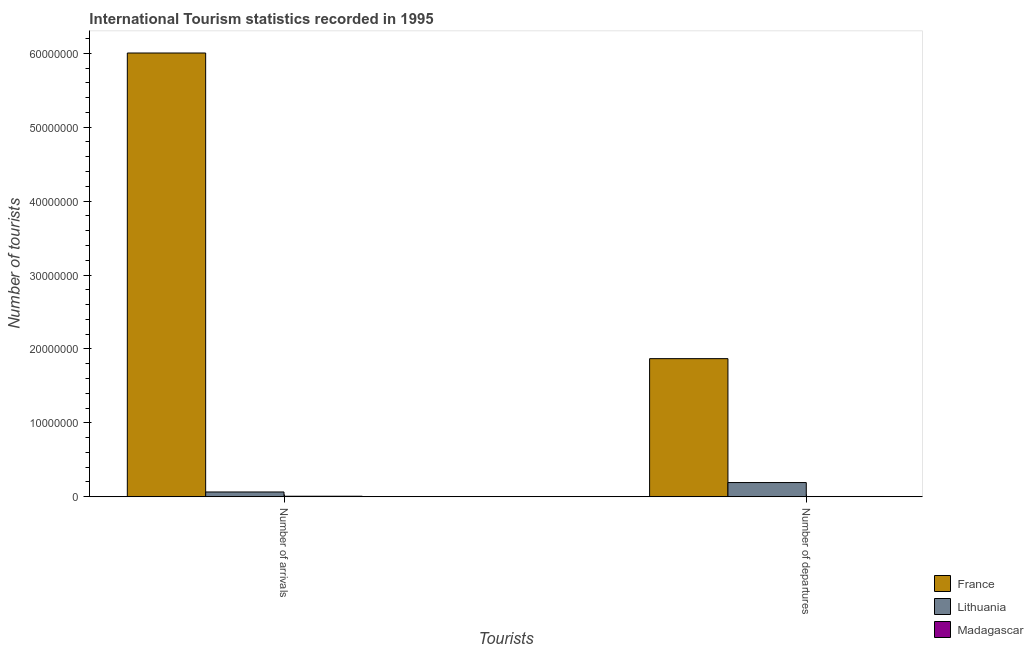Are the number of bars per tick equal to the number of legend labels?
Your answer should be very brief. Yes. What is the label of the 2nd group of bars from the left?
Provide a short and direct response. Number of departures. What is the number of tourist arrivals in France?
Offer a terse response. 6.00e+07. Across all countries, what is the maximum number of tourist departures?
Make the answer very short. 1.87e+07. Across all countries, what is the minimum number of tourist arrivals?
Your answer should be compact. 7.50e+04. In which country was the number of tourist arrivals minimum?
Make the answer very short. Madagascar. What is the total number of tourist arrivals in the graph?
Ensure brevity in your answer.  6.08e+07. What is the difference between the number of tourist arrivals in France and that in Madagascar?
Provide a short and direct response. 6.00e+07. What is the difference between the number of tourist arrivals in Madagascar and the number of tourist departures in France?
Your response must be concise. -1.86e+07. What is the average number of tourist departures per country?
Give a very brief answer. 6.88e+06. What is the difference between the number of tourist arrivals and number of tourist departures in Madagascar?
Give a very brief answer. 3.60e+04. In how many countries, is the number of tourist arrivals greater than 46000000 ?
Ensure brevity in your answer.  1. What is the ratio of the number of tourist arrivals in France to that in Lithuania?
Keep it short and to the point. 92.36. Is the number of tourist departures in Lithuania less than that in France?
Provide a succinct answer. Yes. In how many countries, is the number of tourist arrivals greater than the average number of tourist arrivals taken over all countries?
Ensure brevity in your answer.  1. What does the 1st bar from the left in Number of departures represents?
Your answer should be compact. France. What does the 1st bar from the right in Number of arrivals represents?
Your answer should be very brief. Madagascar. How many bars are there?
Offer a very short reply. 6. Does the graph contain any zero values?
Give a very brief answer. No. How are the legend labels stacked?
Your answer should be very brief. Vertical. What is the title of the graph?
Your answer should be very brief. International Tourism statistics recorded in 1995. Does "Hungary" appear as one of the legend labels in the graph?
Make the answer very short. No. What is the label or title of the X-axis?
Your answer should be very brief. Tourists. What is the label or title of the Y-axis?
Provide a short and direct response. Number of tourists. What is the Number of tourists in France in Number of arrivals?
Ensure brevity in your answer.  6.00e+07. What is the Number of tourists of Lithuania in Number of arrivals?
Keep it short and to the point. 6.50e+05. What is the Number of tourists of Madagascar in Number of arrivals?
Offer a very short reply. 7.50e+04. What is the Number of tourists of France in Number of departures?
Your response must be concise. 1.87e+07. What is the Number of tourists in Lithuania in Number of departures?
Ensure brevity in your answer.  1.92e+06. What is the Number of tourists in Madagascar in Number of departures?
Offer a very short reply. 3.90e+04. Across all Tourists, what is the maximum Number of tourists in France?
Ensure brevity in your answer.  6.00e+07. Across all Tourists, what is the maximum Number of tourists of Lithuania?
Keep it short and to the point. 1.92e+06. Across all Tourists, what is the maximum Number of tourists of Madagascar?
Keep it short and to the point. 7.50e+04. Across all Tourists, what is the minimum Number of tourists in France?
Provide a short and direct response. 1.87e+07. Across all Tourists, what is the minimum Number of tourists of Lithuania?
Offer a very short reply. 6.50e+05. Across all Tourists, what is the minimum Number of tourists of Madagascar?
Ensure brevity in your answer.  3.90e+04. What is the total Number of tourists in France in the graph?
Your response must be concise. 7.87e+07. What is the total Number of tourists of Lithuania in the graph?
Provide a short and direct response. 2.58e+06. What is the total Number of tourists of Madagascar in the graph?
Make the answer very short. 1.14e+05. What is the difference between the Number of tourists in France in Number of arrivals and that in Number of departures?
Offer a very short reply. 4.13e+07. What is the difference between the Number of tourists in Lithuania in Number of arrivals and that in Number of departures?
Ensure brevity in your answer.  -1.28e+06. What is the difference between the Number of tourists of Madagascar in Number of arrivals and that in Number of departures?
Keep it short and to the point. 3.60e+04. What is the difference between the Number of tourists in France in Number of arrivals and the Number of tourists in Lithuania in Number of departures?
Your answer should be compact. 5.81e+07. What is the difference between the Number of tourists of France in Number of arrivals and the Number of tourists of Madagascar in Number of departures?
Make the answer very short. 6.00e+07. What is the difference between the Number of tourists in Lithuania in Number of arrivals and the Number of tourists in Madagascar in Number of departures?
Ensure brevity in your answer.  6.11e+05. What is the average Number of tourists of France per Tourists?
Offer a terse response. 3.94e+07. What is the average Number of tourists in Lithuania per Tourists?
Give a very brief answer. 1.29e+06. What is the average Number of tourists of Madagascar per Tourists?
Your response must be concise. 5.70e+04. What is the difference between the Number of tourists in France and Number of tourists in Lithuania in Number of arrivals?
Provide a short and direct response. 5.94e+07. What is the difference between the Number of tourists of France and Number of tourists of Madagascar in Number of arrivals?
Your response must be concise. 6.00e+07. What is the difference between the Number of tourists in Lithuania and Number of tourists in Madagascar in Number of arrivals?
Offer a very short reply. 5.75e+05. What is the difference between the Number of tourists in France and Number of tourists in Lithuania in Number of departures?
Provide a succinct answer. 1.68e+07. What is the difference between the Number of tourists of France and Number of tourists of Madagascar in Number of departures?
Make the answer very short. 1.86e+07. What is the difference between the Number of tourists in Lithuania and Number of tourists in Madagascar in Number of departures?
Provide a succinct answer. 1.89e+06. What is the ratio of the Number of tourists of France in Number of arrivals to that in Number of departures?
Ensure brevity in your answer.  3.21. What is the ratio of the Number of tourists in Lithuania in Number of arrivals to that in Number of departures?
Ensure brevity in your answer.  0.34. What is the ratio of the Number of tourists in Madagascar in Number of arrivals to that in Number of departures?
Provide a short and direct response. 1.92. What is the difference between the highest and the second highest Number of tourists in France?
Provide a succinct answer. 4.13e+07. What is the difference between the highest and the second highest Number of tourists in Lithuania?
Provide a short and direct response. 1.28e+06. What is the difference between the highest and the second highest Number of tourists in Madagascar?
Your answer should be compact. 3.60e+04. What is the difference between the highest and the lowest Number of tourists of France?
Your answer should be compact. 4.13e+07. What is the difference between the highest and the lowest Number of tourists in Lithuania?
Provide a short and direct response. 1.28e+06. What is the difference between the highest and the lowest Number of tourists in Madagascar?
Your answer should be very brief. 3.60e+04. 